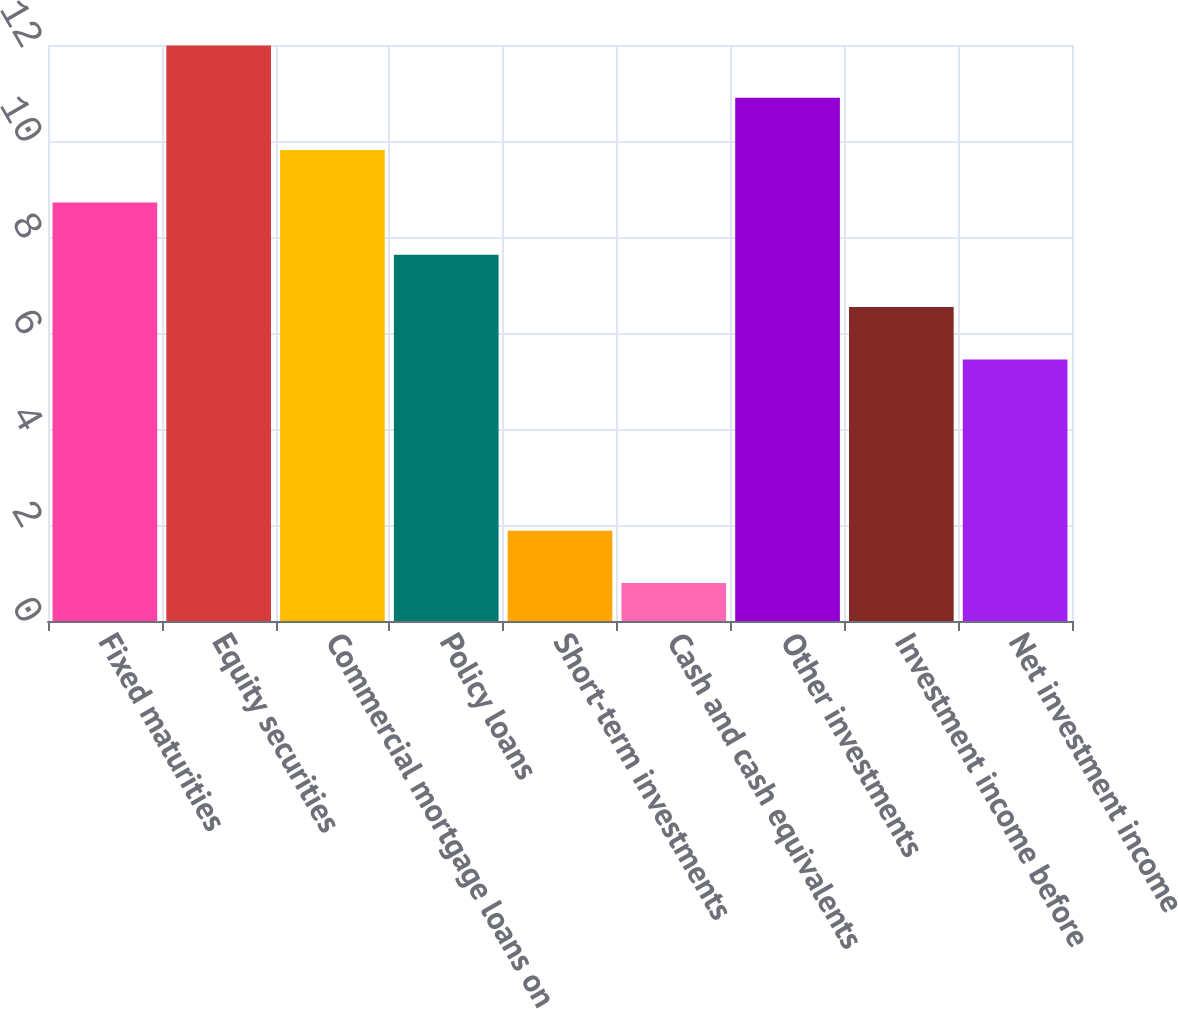<chart> <loc_0><loc_0><loc_500><loc_500><bar_chart><fcel>Fixed maturities<fcel>Equity securities<fcel>Commercial mortgage loans on<fcel>Policy loans<fcel>Short-term investments<fcel>Cash and cash equivalents<fcel>Other investments<fcel>Investment income before<fcel>Net investment income<nl><fcel>8.72<fcel>11.99<fcel>9.81<fcel>7.63<fcel>1.88<fcel>0.79<fcel>10.9<fcel>6.54<fcel>5.45<nl></chart> 